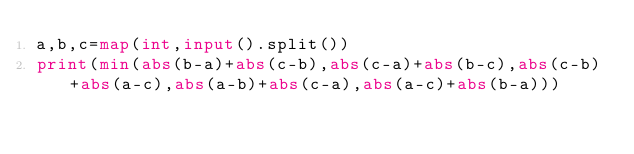<code> <loc_0><loc_0><loc_500><loc_500><_Python_>a,b,c=map(int,input().split())
print(min(abs(b-a)+abs(c-b),abs(c-a)+abs(b-c),abs(c-b)+abs(a-c),abs(a-b)+abs(c-a),abs(a-c)+abs(b-a)))</code> 